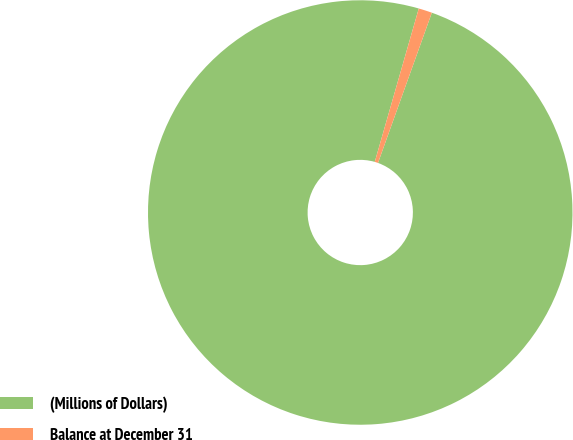Convert chart to OTSL. <chart><loc_0><loc_0><loc_500><loc_500><pie_chart><fcel>(Millions of Dollars)<fcel>Balance at December 31<nl><fcel>98.97%<fcel>1.03%<nl></chart> 